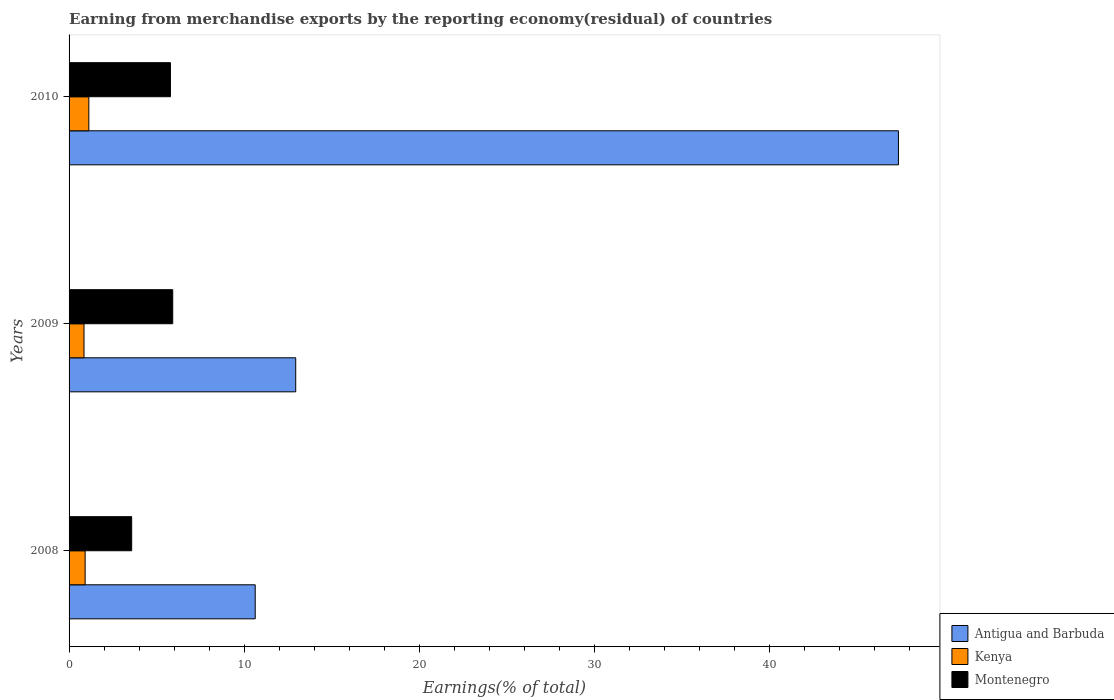How many different coloured bars are there?
Give a very brief answer. 3. How many groups of bars are there?
Give a very brief answer. 3. Are the number of bars per tick equal to the number of legend labels?
Offer a very short reply. Yes. Are the number of bars on each tick of the Y-axis equal?
Make the answer very short. Yes. How many bars are there on the 3rd tick from the bottom?
Your response must be concise. 3. What is the percentage of amount earned from merchandise exports in Montenegro in 2010?
Offer a very short reply. 5.79. Across all years, what is the maximum percentage of amount earned from merchandise exports in Montenegro?
Provide a succinct answer. 5.92. Across all years, what is the minimum percentage of amount earned from merchandise exports in Montenegro?
Make the answer very short. 3.58. In which year was the percentage of amount earned from merchandise exports in Montenegro maximum?
Your response must be concise. 2009. In which year was the percentage of amount earned from merchandise exports in Montenegro minimum?
Provide a short and direct response. 2008. What is the total percentage of amount earned from merchandise exports in Kenya in the graph?
Offer a terse response. 2.9. What is the difference between the percentage of amount earned from merchandise exports in Antigua and Barbuda in 2008 and that in 2009?
Ensure brevity in your answer.  -2.31. What is the difference between the percentage of amount earned from merchandise exports in Kenya in 2009 and the percentage of amount earned from merchandise exports in Montenegro in 2008?
Your response must be concise. -2.72. What is the average percentage of amount earned from merchandise exports in Kenya per year?
Your response must be concise. 0.97. In the year 2009, what is the difference between the percentage of amount earned from merchandise exports in Antigua and Barbuda and percentage of amount earned from merchandise exports in Kenya?
Provide a short and direct response. 12.09. What is the ratio of the percentage of amount earned from merchandise exports in Montenegro in 2008 to that in 2010?
Ensure brevity in your answer.  0.62. What is the difference between the highest and the second highest percentage of amount earned from merchandise exports in Montenegro?
Your response must be concise. 0.13. What is the difference between the highest and the lowest percentage of amount earned from merchandise exports in Antigua and Barbuda?
Provide a succinct answer. 36.73. What does the 1st bar from the top in 2008 represents?
Offer a very short reply. Montenegro. What does the 2nd bar from the bottom in 2010 represents?
Provide a succinct answer. Kenya. Are all the bars in the graph horizontal?
Offer a very short reply. Yes. How many years are there in the graph?
Offer a very short reply. 3. What is the difference between two consecutive major ticks on the X-axis?
Provide a succinct answer. 10. Are the values on the major ticks of X-axis written in scientific E-notation?
Ensure brevity in your answer.  No. Where does the legend appear in the graph?
Provide a succinct answer. Bottom right. How many legend labels are there?
Ensure brevity in your answer.  3. How are the legend labels stacked?
Keep it short and to the point. Vertical. What is the title of the graph?
Give a very brief answer. Earning from merchandise exports by the reporting economy(residual) of countries. Does "Sweden" appear as one of the legend labels in the graph?
Your answer should be compact. No. What is the label or title of the X-axis?
Provide a succinct answer. Earnings(% of total). What is the Earnings(% of total) in Antigua and Barbuda in 2008?
Offer a terse response. 10.63. What is the Earnings(% of total) of Kenya in 2008?
Ensure brevity in your answer.  0.92. What is the Earnings(% of total) in Montenegro in 2008?
Provide a succinct answer. 3.58. What is the Earnings(% of total) of Antigua and Barbuda in 2009?
Offer a terse response. 12.94. What is the Earnings(% of total) of Kenya in 2009?
Keep it short and to the point. 0.85. What is the Earnings(% of total) in Montenegro in 2009?
Give a very brief answer. 5.92. What is the Earnings(% of total) of Antigua and Barbuda in 2010?
Your answer should be very brief. 47.36. What is the Earnings(% of total) in Kenya in 2010?
Your answer should be compact. 1.13. What is the Earnings(% of total) in Montenegro in 2010?
Ensure brevity in your answer.  5.79. Across all years, what is the maximum Earnings(% of total) of Antigua and Barbuda?
Your answer should be compact. 47.36. Across all years, what is the maximum Earnings(% of total) in Kenya?
Provide a short and direct response. 1.13. Across all years, what is the maximum Earnings(% of total) of Montenegro?
Your response must be concise. 5.92. Across all years, what is the minimum Earnings(% of total) of Antigua and Barbuda?
Ensure brevity in your answer.  10.63. Across all years, what is the minimum Earnings(% of total) of Kenya?
Make the answer very short. 0.85. Across all years, what is the minimum Earnings(% of total) in Montenegro?
Ensure brevity in your answer.  3.58. What is the total Earnings(% of total) of Antigua and Barbuda in the graph?
Your response must be concise. 70.94. What is the total Earnings(% of total) in Kenya in the graph?
Offer a very short reply. 2.9. What is the total Earnings(% of total) of Montenegro in the graph?
Provide a succinct answer. 15.28. What is the difference between the Earnings(% of total) in Antigua and Barbuda in 2008 and that in 2009?
Provide a succinct answer. -2.31. What is the difference between the Earnings(% of total) in Kenya in 2008 and that in 2009?
Your response must be concise. 0.06. What is the difference between the Earnings(% of total) of Montenegro in 2008 and that in 2009?
Keep it short and to the point. -2.34. What is the difference between the Earnings(% of total) in Antigua and Barbuda in 2008 and that in 2010?
Ensure brevity in your answer.  -36.73. What is the difference between the Earnings(% of total) of Kenya in 2008 and that in 2010?
Provide a short and direct response. -0.21. What is the difference between the Earnings(% of total) of Montenegro in 2008 and that in 2010?
Your answer should be compact. -2.21. What is the difference between the Earnings(% of total) of Antigua and Barbuda in 2009 and that in 2010?
Offer a terse response. -34.42. What is the difference between the Earnings(% of total) in Kenya in 2009 and that in 2010?
Provide a succinct answer. -0.28. What is the difference between the Earnings(% of total) of Montenegro in 2009 and that in 2010?
Your answer should be compact. 0.13. What is the difference between the Earnings(% of total) in Antigua and Barbuda in 2008 and the Earnings(% of total) in Kenya in 2009?
Your response must be concise. 9.78. What is the difference between the Earnings(% of total) in Antigua and Barbuda in 2008 and the Earnings(% of total) in Montenegro in 2009?
Make the answer very short. 4.71. What is the difference between the Earnings(% of total) of Kenya in 2008 and the Earnings(% of total) of Montenegro in 2009?
Offer a terse response. -5. What is the difference between the Earnings(% of total) of Antigua and Barbuda in 2008 and the Earnings(% of total) of Kenya in 2010?
Offer a very short reply. 9.5. What is the difference between the Earnings(% of total) in Antigua and Barbuda in 2008 and the Earnings(% of total) in Montenegro in 2010?
Offer a very short reply. 4.84. What is the difference between the Earnings(% of total) of Kenya in 2008 and the Earnings(% of total) of Montenegro in 2010?
Offer a very short reply. -4.87. What is the difference between the Earnings(% of total) of Antigua and Barbuda in 2009 and the Earnings(% of total) of Kenya in 2010?
Make the answer very short. 11.81. What is the difference between the Earnings(% of total) in Antigua and Barbuda in 2009 and the Earnings(% of total) in Montenegro in 2010?
Your response must be concise. 7.15. What is the difference between the Earnings(% of total) in Kenya in 2009 and the Earnings(% of total) in Montenegro in 2010?
Make the answer very short. -4.94. What is the average Earnings(% of total) in Antigua and Barbuda per year?
Provide a succinct answer. 23.65. What is the average Earnings(% of total) of Kenya per year?
Your answer should be compact. 0.97. What is the average Earnings(% of total) of Montenegro per year?
Your answer should be compact. 5.09. In the year 2008, what is the difference between the Earnings(% of total) in Antigua and Barbuda and Earnings(% of total) in Kenya?
Your response must be concise. 9.71. In the year 2008, what is the difference between the Earnings(% of total) in Antigua and Barbuda and Earnings(% of total) in Montenegro?
Offer a terse response. 7.06. In the year 2008, what is the difference between the Earnings(% of total) of Kenya and Earnings(% of total) of Montenegro?
Offer a very short reply. -2.66. In the year 2009, what is the difference between the Earnings(% of total) in Antigua and Barbuda and Earnings(% of total) in Kenya?
Offer a terse response. 12.09. In the year 2009, what is the difference between the Earnings(% of total) of Antigua and Barbuda and Earnings(% of total) of Montenegro?
Keep it short and to the point. 7.02. In the year 2009, what is the difference between the Earnings(% of total) of Kenya and Earnings(% of total) of Montenegro?
Your response must be concise. -5.07. In the year 2010, what is the difference between the Earnings(% of total) of Antigua and Barbuda and Earnings(% of total) of Kenya?
Provide a short and direct response. 46.23. In the year 2010, what is the difference between the Earnings(% of total) in Antigua and Barbuda and Earnings(% of total) in Montenegro?
Provide a succinct answer. 41.57. In the year 2010, what is the difference between the Earnings(% of total) of Kenya and Earnings(% of total) of Montenegro?
Give a very brief answer. -4.66. What is the ratio of the Earnings(% of total) of Antigua and Barbuda in 2008 to that in 2009?
Your answer should be compact. 0.82. What is the ratio of the Earnings(% of total) in Kenya in 2008 to that in 2009?
Make the answer very short. 1.08. What is the ratio of the Earnings(% of total) in Montenegro in 2008 to that in 2009?
Offer a very short reply. 0.6. What is the ratio of the Earnings(% of total) in Antigua and Barbuda in 2008 to that in 2010?
Your response must be concise. 0.22. What is the ratio of the Earnings(% of total) in Kenya in 2008 to that in 2010?
Offer a terse response. 0.81. What is the ratio of the Earnings(% of total) in Montenegro in 2008 to that in 2010?
Keep it short and to the point. 0.62. What is the ratio of the Earnings(% of total) in Antigua and Barbuda in 2009 to that in 2010?
Your answer should be compact. 0.27. What is the ratio of the Earnings(% of total) of Kenya in 2009 to that in 2010?
Offer a very short reply. 0.76. What is the ratio of the Earnings(% of total) in Montenegro in 2009 to that in 2010?
Keep it short and to the point. 1.02. What is the difference between the highest and the second highest Earnings(% of total) of Antigua and Barbuda?
Give a very brief answer. 34.42. What is the difference between the highest and the second highest Earnings(% of total) of Kenya?
Provide a succinct answer. 0.21. What is the difference between the highest and the second highest Earnings(% of total) in Montenegro?
Keep it short and to the point. 0.13. What is the difference between the highest and the lowest Earnings(% of total) in Antigua and Barbuda?
Your answer should be very brief. 36.73. What is the difference between the highest and the lowest Earnings(% of total) of Kenya?
Your answer should be compact. 0.28. What is the difference between the highest and the lowest Earnings(% of total) in Montenegro?
Your answer should be very brief. 2.34. 